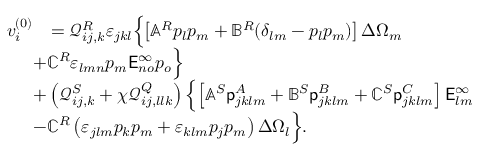<formula> <loc_0><loc_0><loc_500><loc_500>\begin{array} { r l } { v _ { i } ^ { ( 0 ) } } & { = \mathcal { Q } _ { i j , k } ^ { R } \varepsilon _ { j k l } \left \{ \left [ \mathbb { A } ^ { R } p _ { l } p _ { m } + \mathbb { B } ^ { R } ( \delta _ { l m } - p _ { l } p _ { m } ) \right ] \Delta \Omega _ { m } } \\ & { \, + \mathbb { C } ^ { R } \varepsilon _ { l m n } p _ { m } E _ { n o } ^ { \infty } p _ { o } \right \} } \\ & { \, + \left ( \mathcal { Q } _ { i j , k } ^ { S } + \chi \mathcal { Q } _ { i j , l l k } ^ { Q } \right ) \left \{ \left [ \mathbb { A } ^ { S } { p _ { j k l m } ^ { A } } + \mathbb { B } ^ { S } { p _ { j k l m } ^ { B } } + \mathbb { C } ^ { S } { p _ { j k l m } ^ { C } } \right ] E _ { l m } ^ { \infty } } \\ & { \, - \mathbb { C } ^ { R } \left ( \varepsilon _ { j l m } p _ { k } p _ { m } + \varepsilon _ { k l m } p _ { j } p _ { m } \right ) \Delta \Omega _ { l } \right \} . } \end{array}</formula> 